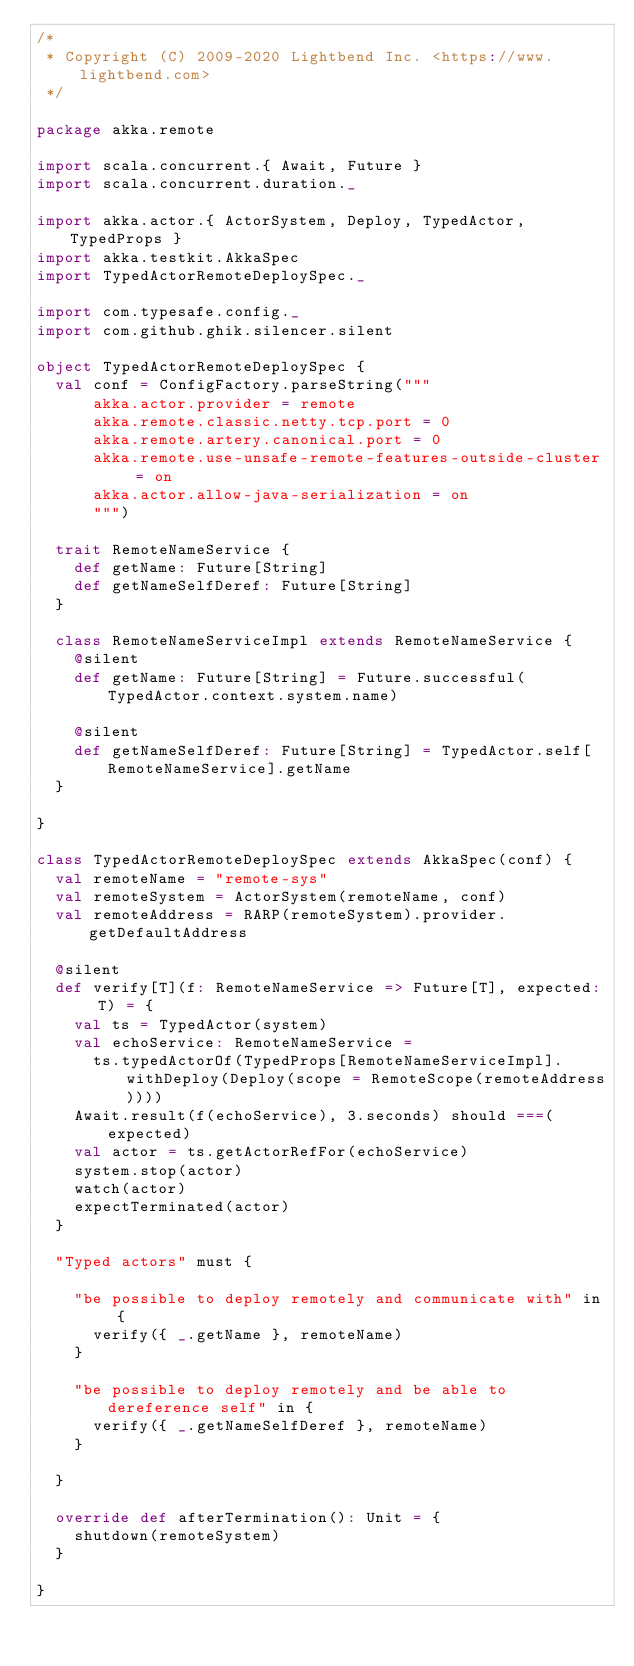Convert code to text. <code><loc_0><loc_0><loc_500><loc_500><_Scala_>/*
 * Copyright (C) 2009-2020 Lightbend Inc. <https://www.lightbend.com>
 */

package akka.remote

import scala.concurrent.{ Await, Future }
import scala.concurrent.duration._

import akka.actor.{ ActorSystem, Deploy, TypedActor, TypedProps }
import akka.testkit.AkkaSpec
import TypedActorRemoteDeploySpec._

import com.typesafe.config._
import com.github.ghik.silencer.silent

object TypedActorRemoteDeploySpec {
  val conf = ConfigFactory.parseString("""
      akka.actor.provider = remote
      akka.remote.classic.netty.tcp.port = 0
      akka.remote.artery.canonical.port = 0
      akka.remote.use-unsafe-remote-features-outside-cluster = on
      akka.actor.allow-java-serialization = on
      """)

  trait RemoteNameService {
    def getName: Future[String]
    def getNameSelfDeref: Future[String]
  }

  class RemoteNameServiceImpl extends RemoteNameService {
    @silent
    def getName: Future[String] = Future.successful(TypedActor.context.system.name)

    @silent
    def getNameSelfDeref: Future[String] = TypedActor.self[RemoteNameService].getName
  }

}

class TypedActorRemoteDeploySpec extends AkkaSpec(conf) {
  val remoteName = "remote-sys"
  val remoteSystem = ActorSystem(remoteName, conf)
  val remoteAddress = RARP(remoteSystem).provider.getDefaultAddress

  @silent
  def verify[T](f: RemoteNameService => Future[T], expected: T) = {
    val ts = TypedActor(system)
    val echoService: RemoteNameService =
      ts.typedActorOf(TypedProps[RemoteNameServiceImpl].withDeploy(Deploy(scope = RemoteScope(remoteAddress))))
    Await.result(f(echoService), 3.seconds) should ===(expected)
    val actor = ts.getActorRefFor(echoService)
    system.stop(actor)
    watch(actor)
    expectTerminated(actor)
  }

  "Typed actors" must {

    "be possible to deploy remotely and communicate with" in {
      verify({ _.getName }, remoteName)
    }

    "be possible to deploy remotely and be able to dereference self" in {
      verify({ _.getNameSelfDeref }, remoteName)
    }

  }

  override def afterTermination(): Unit = {
    shutdown(remoteSystem)
  }

}
</code> 